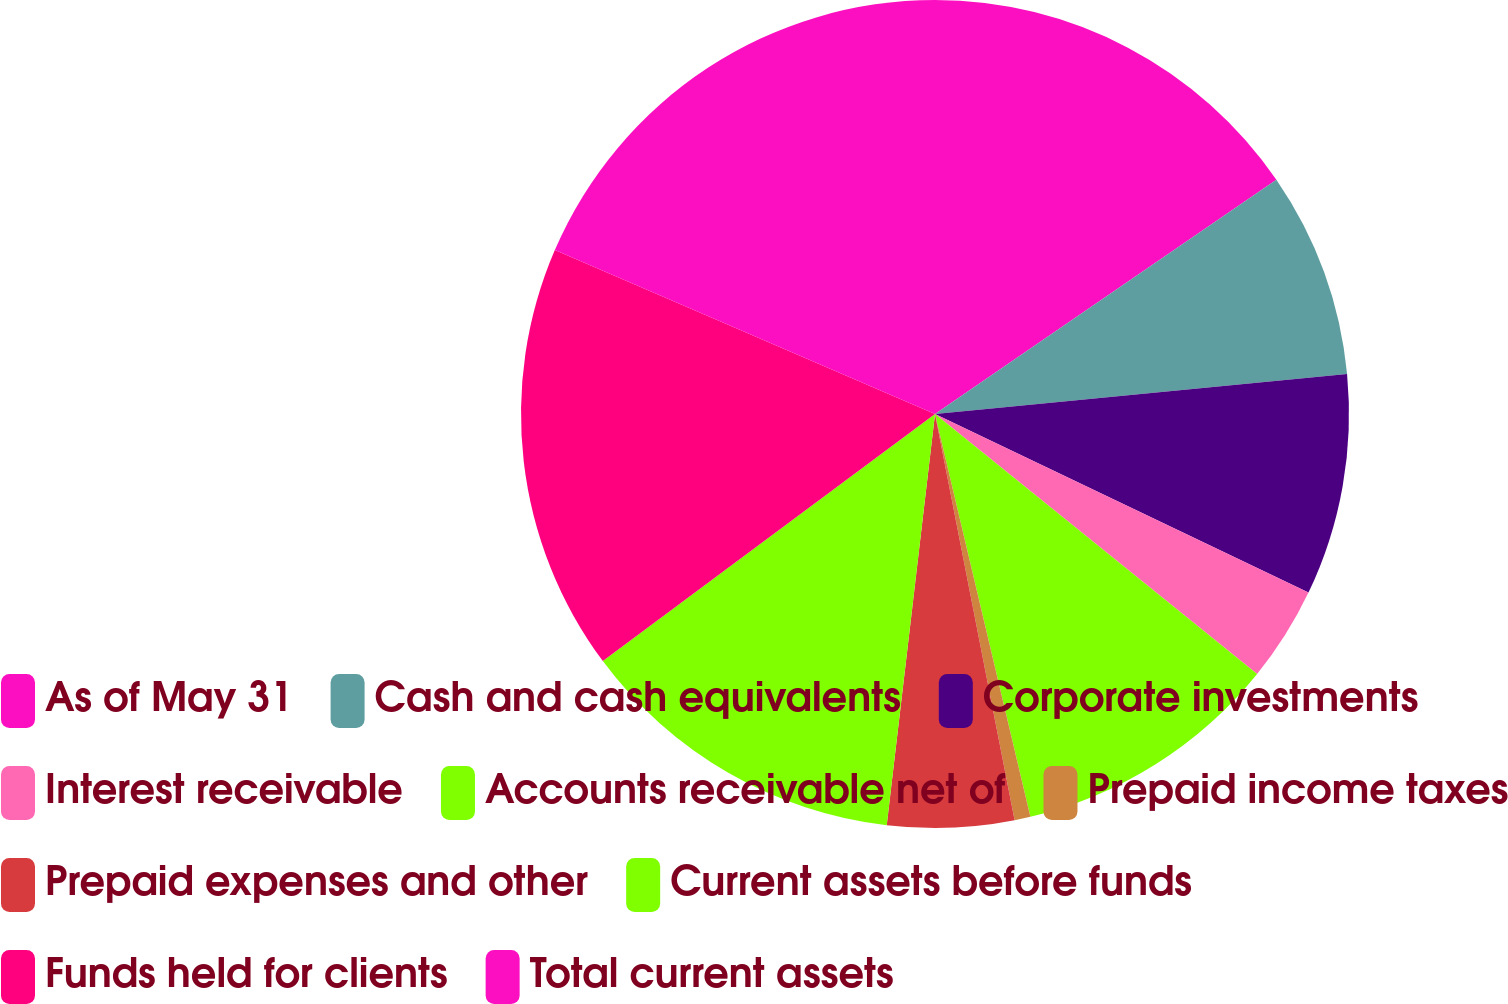<chart> <loc_0><loc_0><loc_500><loc_500><pie_chart><fcel>As of May 31<fcel>Cash and cash equivalents<fcel>Corporate investments<fcel>Interest receivable<fcel>Accounts receivable net of<fcel>Prepaid income taxes<fcel>Prepaid expenses and other<fcel>Current assets before funds<fcel>Funds held for clients<fcel>Total current assets<nl><fcel>15.43%<fcel>8.03%<fcel>8.64%<fcel>3.71%<fcel>10.49%<fcel>0.62%<fcel>4.94%<fcel>12.96%<fcel>16.66%<fcel>18.52%<nl></chart> 